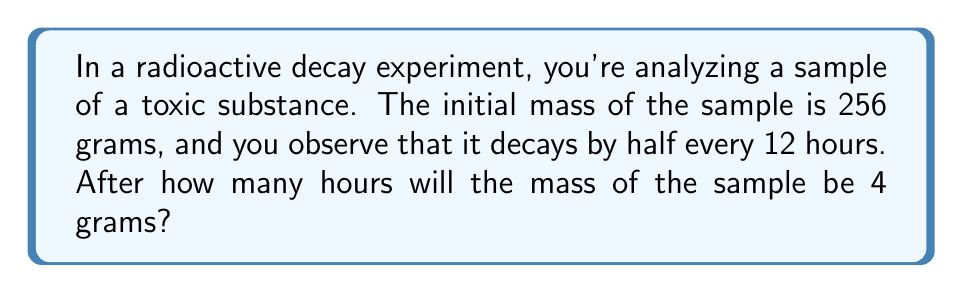Show me your answer to this math problem. Let's approach this step-by-step:

1) This is a geometric sequence where each term is half of the previous term. The common ratio is $r = \frac{1}{2}$.

2) We can represent the mass after $n$ 12-hour periods as:

   $$a_n = 256 \cdot \left(\frac{1}{2}\right)^n$$

3) We want to find $n$ when $a_n = 4$. So we can set up the equation:

   $$4 = 256 \cdot \left(\frac{1}{2}\right)^n$$

4) Divide both sides by 4:

   $$1 = 64 \cdot \left(\frac{1}{2}\right)^n$$

5) Take the logarithm of both sides:

   $$\log_2 1 = \log_2 \left(64 \cdot \left(\frac{1}{2}\right)^n\right)$$

6) Use the logarithm product rule:

   $$0 = \log_2 64 + n \log_2 \left(\frac{1}{2}\right)$$

7) Simplify:

   $$0 = 6 - n$$

8) Solve for $n$:

   $$n = 6$$

9) This means it takes 6 12-hour periods for the mass to reach 4 grams.

10) To convert to hours, multiply by 12:

    $$6 \cdot 12 = 72\text{ hours}$$

Therefore, it will take 72 hours for the sample to decay to 4 grams.
Answer: 72 hours 